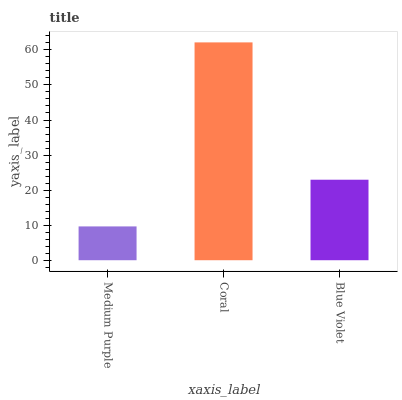Is Medium Purple the minimum?
Answer yes or no. Yes. Is Coral the maximum?
Answer yes or no. Yes. Is Blue Violet the minimum?
Answer yes or no. No. Is Blue Violet the maximum?
Answer yes or no. No. Is Coral greater than Blue Violet?
Answer yes or no. Yes. Is Blue Violet less than Coral?
Answer yes or no. Yes. Is Blue Violet greater than Coral?
Answer yes or no. No. Is Coral less than Blue Violet?
Answer yes or no. No. Is Blue Violet the high median?
Answer yes or no. Yes. Is Blue Violet the low median?
Answer yes or no. Yes. Is Coral the high median?
Answer yes or no. No. Is Coral the low median?
Answer yes or no. No. 